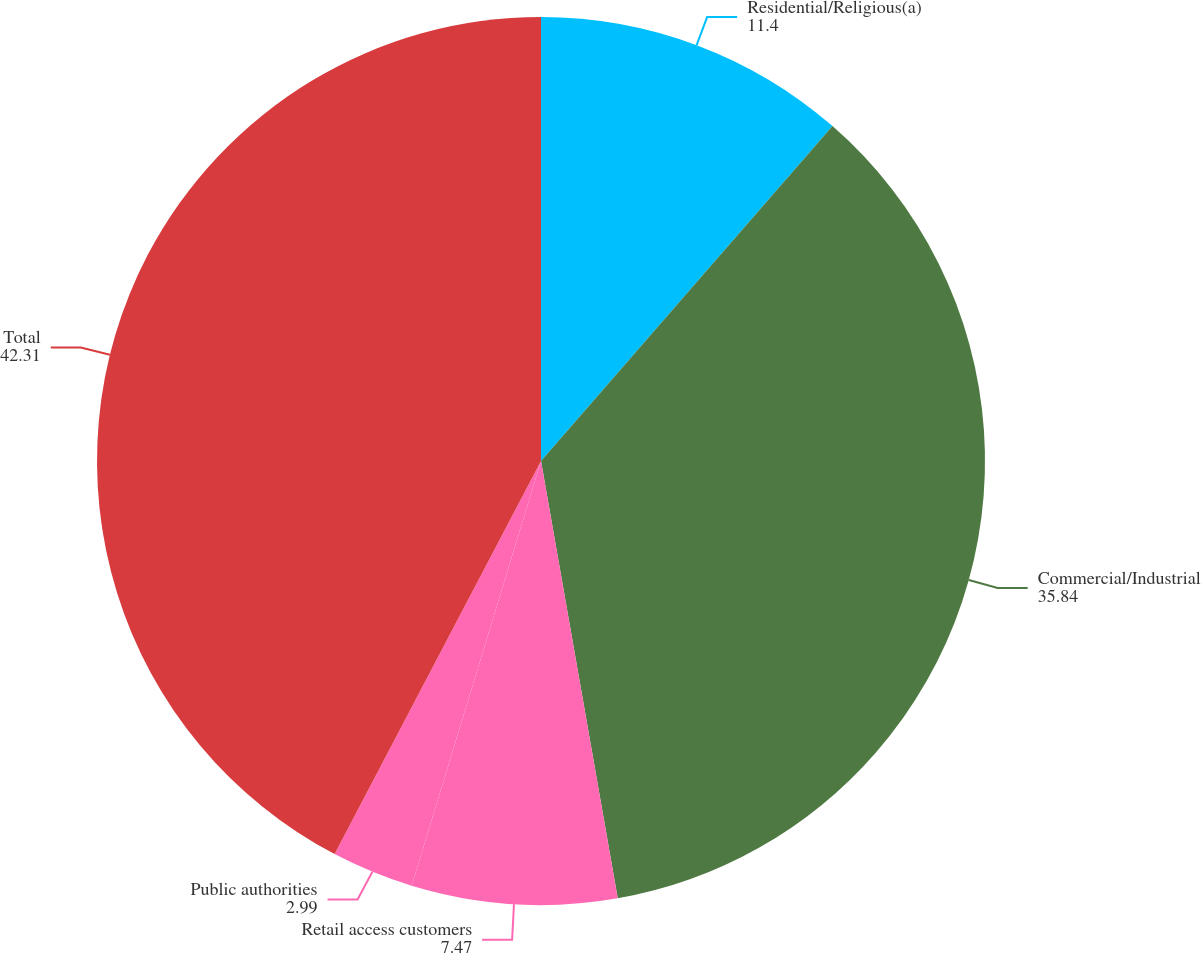<chart> <loc_0><loc_0><loc_500><loc_500><pie_chart><fcel>Residential/Religious(a)<fcel>Commercial/Industrial<fcel>Retail access customers<fcel>Public authorities<fcel>Total<nl><fcel>11.4%<fcel>35.84%<fcel>7.47%<fcel>2.99%<fcel>42.31%<nl></chart> 